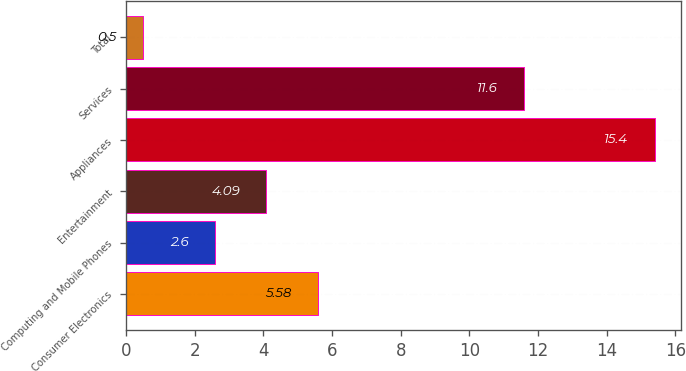Convert chart. <chart><loc_0><loc_0><loc_500><loc_500><bar_chart><fcel>Consumer Electronics<fcel>Computing and Mobile Phones<fcel>Entertainment<fcel>Appliances<fcel>Services<fcel>Total<nl><fcel>5.58<fcel>2.6<fcel>4.09<fcel>15.4<fcel>11.6<fcel>0.5<nl></chart> 